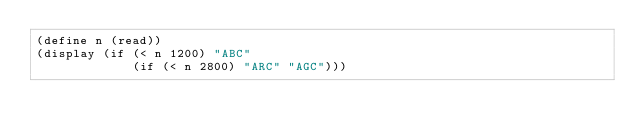Convert code to text. <code><loc_0><loc_0><loc_500><loc_500><_Scheme_>(define n (read))
(display (if (< n 1200) "ABC"
             (if (< n 2800) "ARC" "AGC")))</code> 